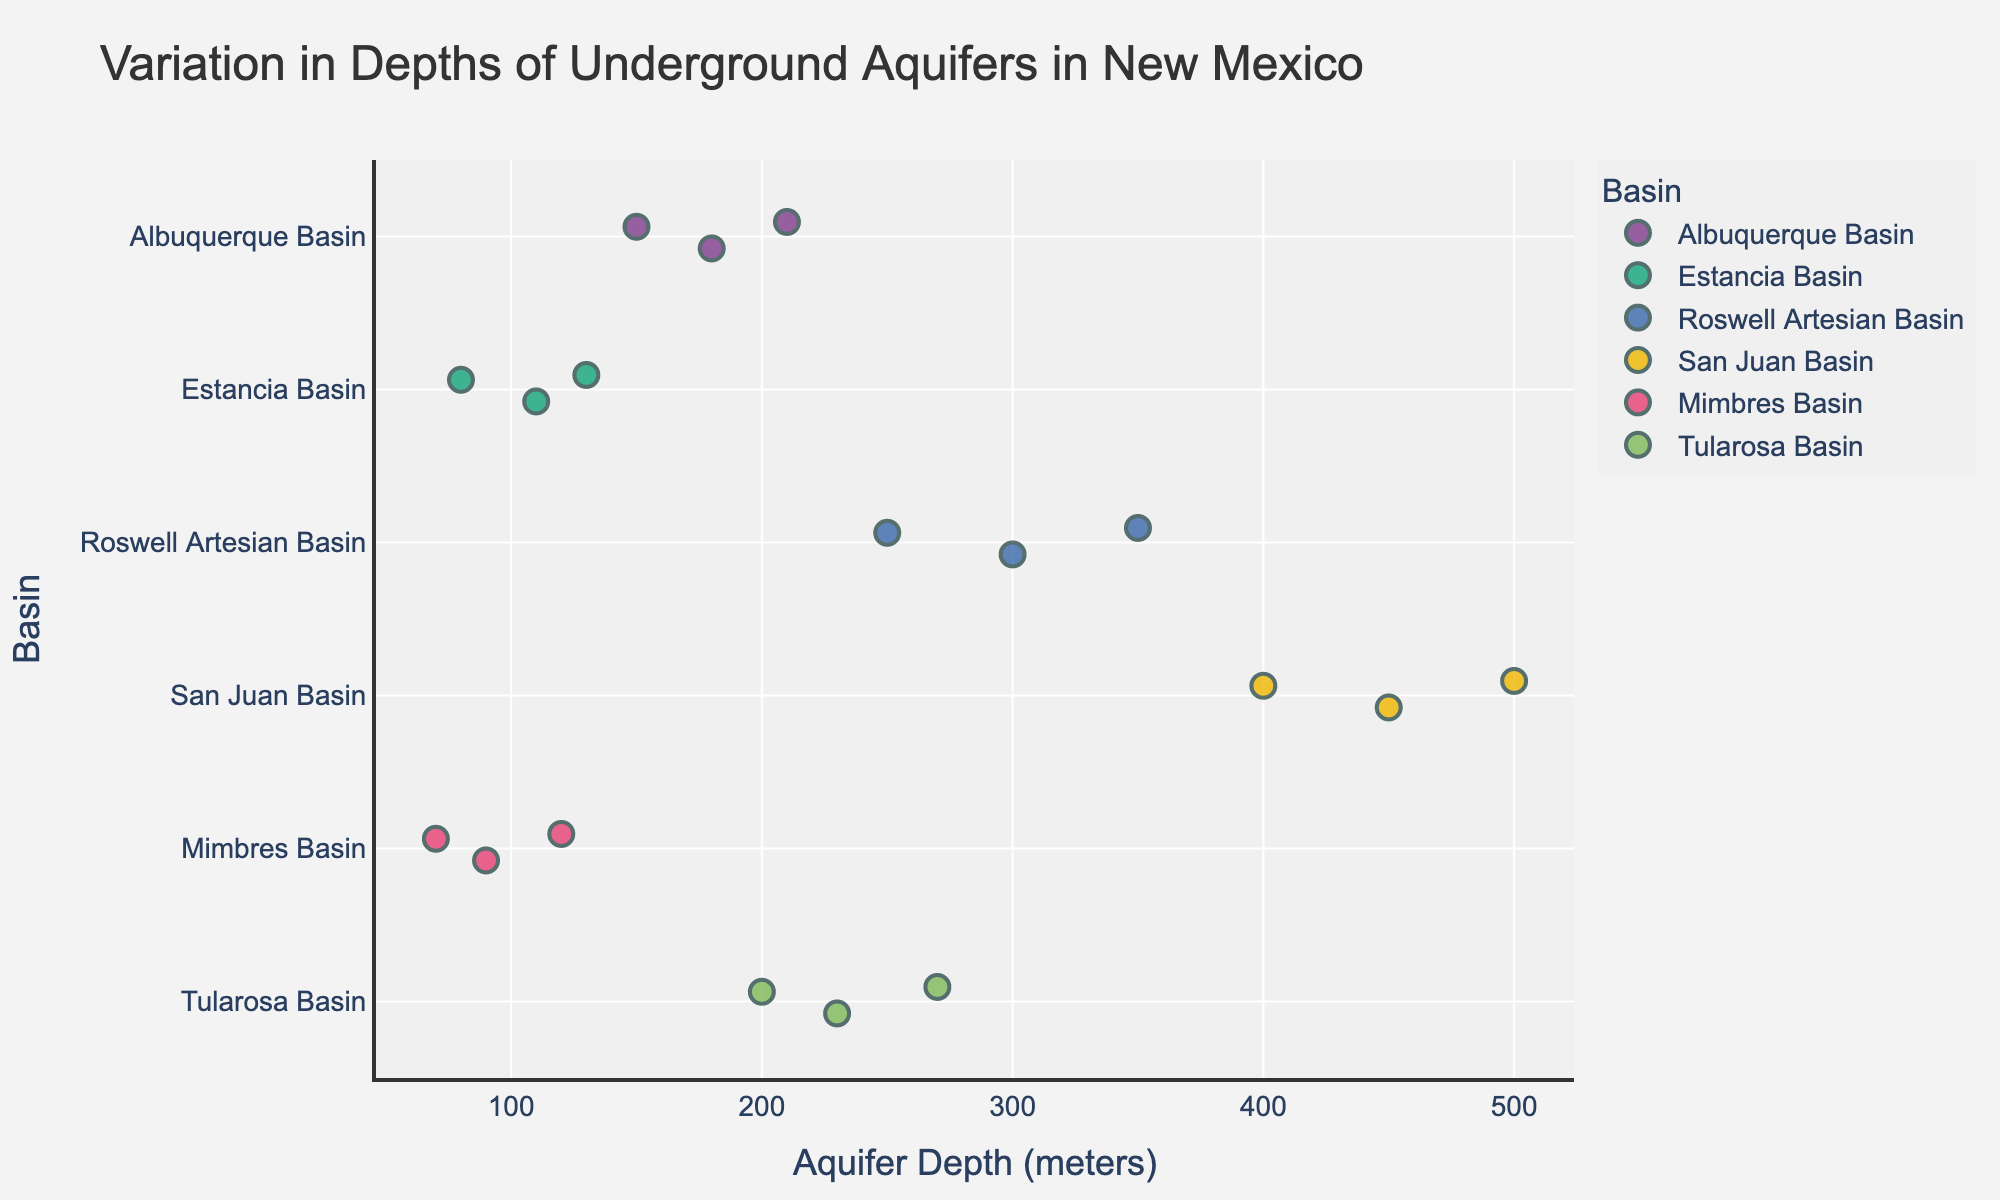What's the title of the strip plot? The title of the strip plot is displayed prominently at the top of the figure. It gives an overall description of the content of the plot.
Answer: "Variation in Depths of Underground Aquifers in New Mexico" Which basin has the deepest aquifer depths in the figure? By observing the horizontal axis and noting the maximum values, we can identify that the San Juan Basin has the deepest aquifer depths, reaching up to 500 meters.
Answer: San Juan Basin How many data points represent the Mimbres Basin? By counting the dot markers for the Mimbres Basin along the vertical axis, we determine that there are 3 data points.
Answer: 3 In which region are the aquifer depths more varied? By comparing the spread of data points along the horizontal axis for each basin, the Roswell Artesian Basin shows the largest range of aquifer depths from 250 to 350 meters.
Answer: Roswell Artesian Basin Which basin has the shallowest minimum depth, and what is that depth? By identifying the smallest value along the horizontal axis and correlating it with its basin, we find that the Mimbres Basin has the shallowest minimum depth of 70 meters.
Answer: Mimbres Basin What is the average depth of the aquifers in the Albuquerque Basin? To find the average depth of the aquifers in the Albuquerque Basin, sum the depths (150 + 180 + 210) and divide by the number of data points (3). The calculation is (150 + 180 + 210) / 3 = 540 / 3 = 180 meters.
Answer: 180 meters Is the deepest aquifer depth in the Mimbres Basin greater than the shallowest depth in the Roswell Artesian Basin? By comparing the deepest point in the Mimbres Basin (120 meters) with the shallowest point in the Roswell Artesian Basin (250 meters), we see that 120 meters is less than 250 meters.
Answer: No Which two basins have the closest range of aquifer depths? By comparing the range (maximum - minimum) of aquifer depths for each basin, we see that the Tularosa Basin (270 - 200 = 70 meters) and the Estancia Basin (130 - 80 = 50 meters) have relatively close ranges.
Answer: Estancia Basin and Tularosa Basin How does the variability in aquifer depths in the Estancia Basin compare to those in the Tularosa Basin? The range of depths in the Estancia Basin is from 80 to 130 meters (50-meter range), while in the Tularosa Basin, it ranges from 200 to 270 meters (70-meter range). Therefore, the Tularosa Basin has a wider range.
Answer: The Tularosa Basin has greater variability Identify the basins where the depth spread does not exceed 100 meters. By calculating the depth spreads for each basin, we see that the Estancia Basin (50 meters) and the Albuquerque Basin (60 meters) have spreads that do not exceed 100 meters.
Answer: Estancia Basin and Albuquerque Basin 